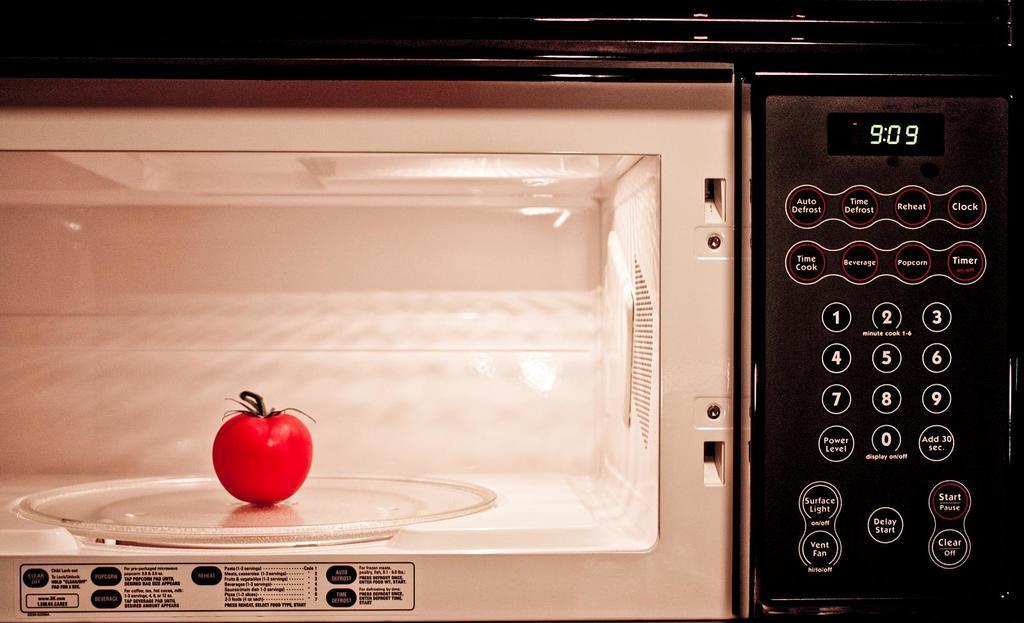In one or two sentences, can you explain what this image depicts? In this image we can see a tomato in an oven. 